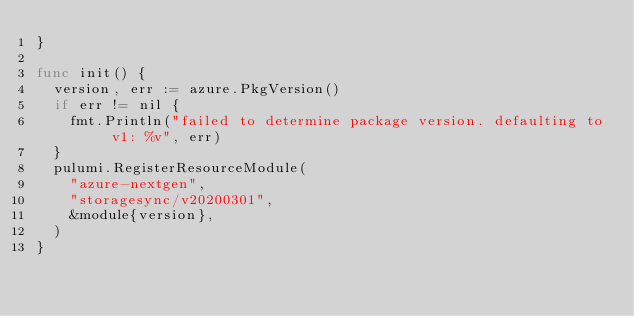<code> <loc_0><loc_0><loc_500><loc_500><_Go_>}

func init() {
	version, err := azure.PkgVersion()
	if err != nil {
		fmt.Println("failed to determine package version. defaulting to v1: %v", err)
	}
	pulumi.RegisterResourceModule(
		"azure-nextgen",
		"storagesync/v20200301",
		&module{version},
	)
}
</code> 